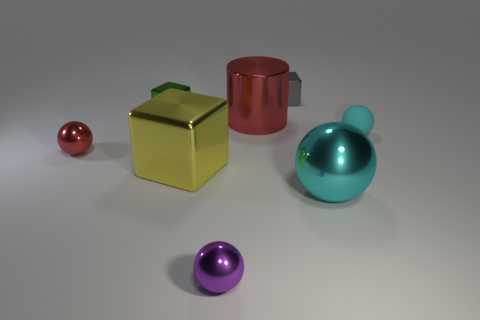Add 1 tiny metallic cubes. How many objects exist? 9 Subtract all cylinders. How many objects are left? 7 Add 1 large gray matte objects. How many large gray matte objects exist? 1 Subtract 1 red balls. How many objects are left? 7 Subtract all large gray matte cylinders. Subtract all big cyan metal balls. How many objects are left? 7 Add 3 tiny cyan things. How many tiny cyan things are left? 4 